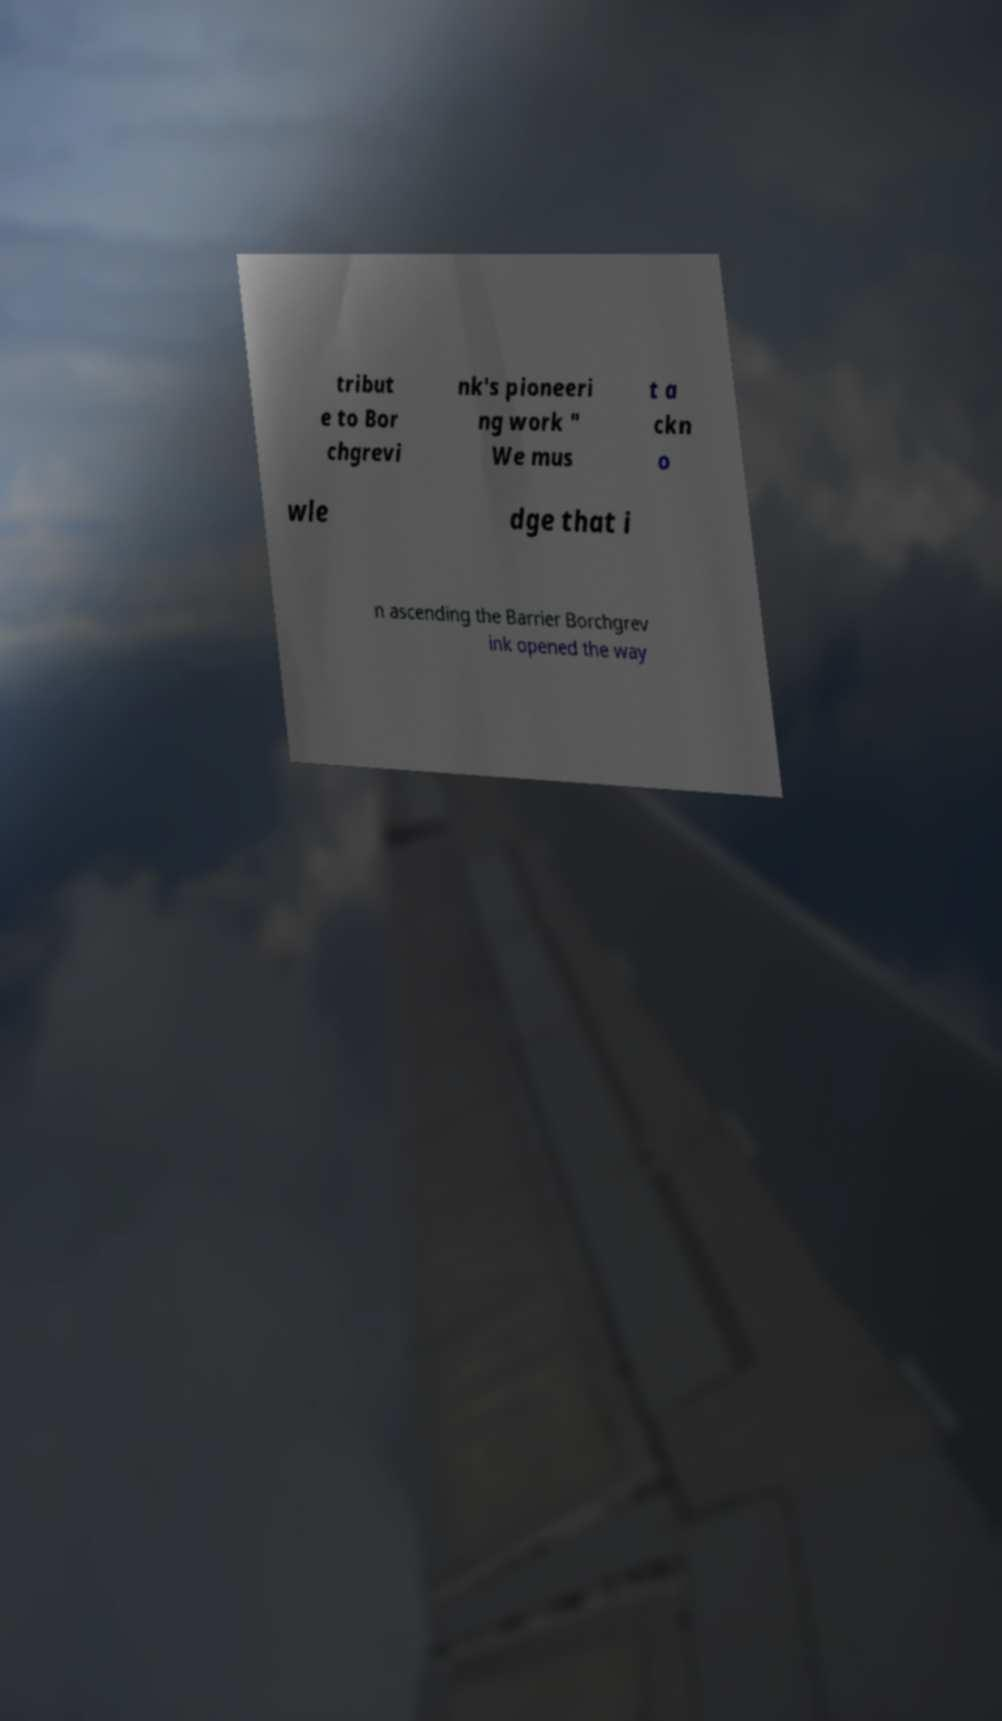Could you extract and type out the text from this image? tribut e to Bor chgrevi nk's pioneeri ng work " We mus t a ckn o wle dge that i n ascending the Barrier Borchgrev ink opened the way 